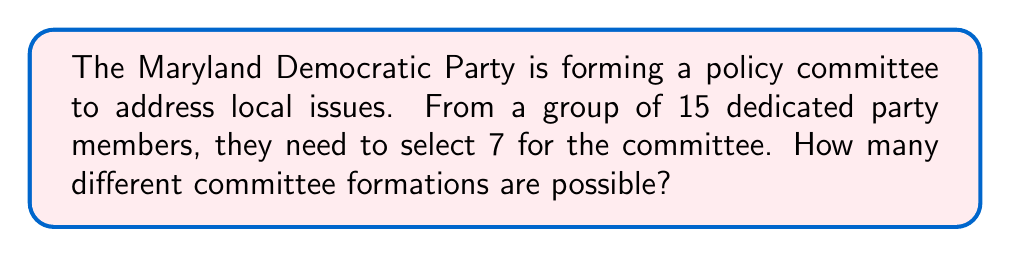Teach me how to tackle this problem. Let's approach this step-by-step:

1) This is a combination problem. We are selecting 7 people from a group of 15, where the order of selection doesn't matter.

2) The formula for combinations is:

   $$C(n,r) = \frac{n!}{r!(n-r)!}$$

   where $n$ is the total number of items to choose from, and $r$ is the number of items being chosen.

3) In this case, $n = 15$ (total party members) and $r = 7$ (committee size).

4) Let's substitute these values into our formula:

   $$C(15,7) = \frac{15!}{7!(15-7)!} = \frac{15!}{7!(8)!}$$

5) Expand this:
   $$\frac{15 \cdot 14 \cdot 13 \cdot 12 \cdot 11 \cdot 10 \cdot 9 \cdot 8!}{(7 \cdot 6 \cdot 5 \cdot 4 \cdot 3 \cdot 2 \cdot 1) \cdot 8!}$$

6) The 8! cancels out in the numerator and denominator:

   $$\frac{15 \cdot 14 \cdot 13 \cdot 12 \cdot 11 \cdot 10 \cdot 9}{7 \cdot 6 \cdot 5 \cdot 4 \cdot 3 \cdot 2 \cdot 1}$$

7) Calculate:
   $$\frac{240,374,016}{5,040} = 6,435$$

Thus, there are 6,435 different possible committee formations.
Answer: 6,435 